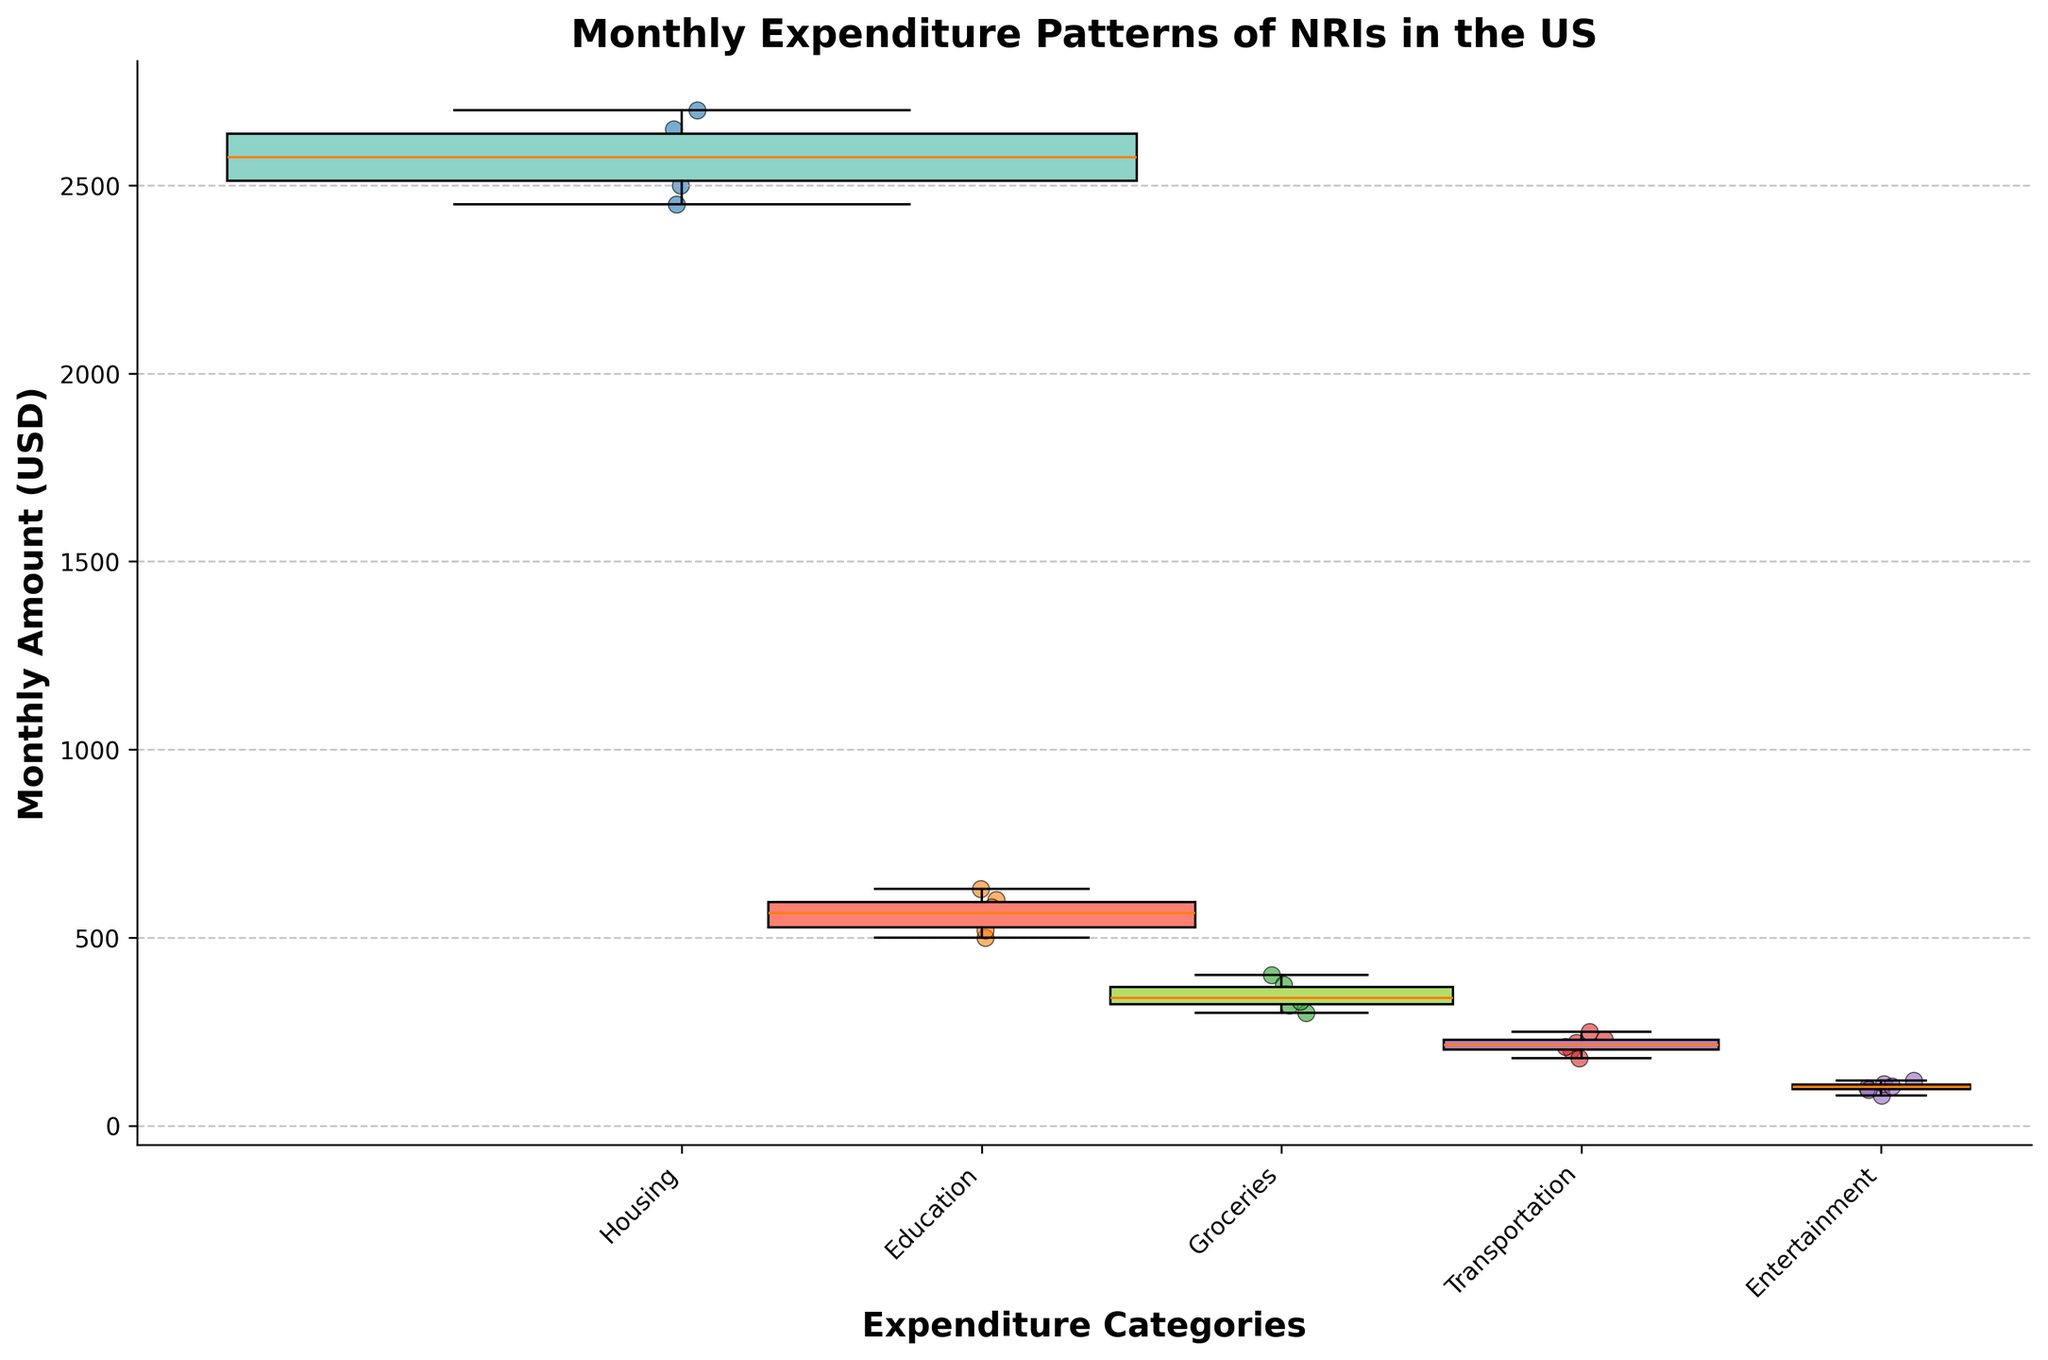What is the title of the plot? The title is displayed above the figure and summarizes the content of the plot; in this case, it is: "Monthly Expenditure Patterns of NRIs in the US."
Answer: Monthly Expenditure Patterns of NRIs in the US What are the categories of expenditure shown in the plot? The categories are listed on the x-axis of the plot. Each tick on the x-axis represents a different category: "Housing," "Education," "Groceries," "Transportation," and "Entertainment."
Answer: Housing, Education, Groceries, Transportation, Entertainment Which category has the highest median expenditure? To find the highest median, look at the box in each box plot and identify the line inside the box representing the median. Compare the medians across categories to determine which is the highest. "Housing" has the highest median line.
Answer: Housing Which category appears to exhibit the most variation in expenditure? Variation is indicated by the interquartile range (IQR), which is represented by the height of the box in a box plot. The category with the largest box height has the most variation. "Housing" has the tallest box span indicating the most variation.
Answer: Housing What is the range of expenditure for the category "Education"? The range is found by identifying the endpoints of the box and whiskers for "Education". The whiskers represent the minimum and maximum expenditure. The minimum is around 500, and the maximum is around 630, giving a range of 630 - 500.
Answer: 130 How do the average weights of the categories compare? The widths of the boxes depend on the weights of the categories. Wider boxes indicate higher average weights. "Housing" has the widest box, followed by "Education", "Groceries", "Transportation", and "Entertainment" in decreasing order of weight.
Answer: Housing > Education > Groceries > Transportation > Entertainment Which category has the smallest overall expenditure? The smallest overall expenditure can be identified by looking at the minimum values (lower whiskers) across categories. "Entertainment" shows the lowest minimum expenditure.
Answer: Entertainment What is the interquartile range (IQR) for the Groceries category? The IQR is the range between the 1st quartile (bottom of the box) and the 3rd quartile (top of the box). For "Groceries", the bottom of the box is around 320, and the top is around 375, giving an IQR of 375 - 320.
Answer: 55 Which category shows the highest number of data points as scatter points? The scatter points indicate individual data points. Count the points overlaying each box plot. "Housing" has the highest number, with six scatter points.
Answer: Housing 